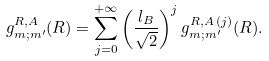Convert formula to latex. <formula><loc_0><loc_0><loc_500><loc_500>g _ { m ; m ^ { \prime } } ^ { R , A } ( { R } ) = \sum _ { j = 0 } ^ { + \infty } \left ( \frac { l _ { B } } { \sqrt { 2 } } \right ) ^ { j } g _ { m ; m ^ { \prime } } ^ { R , A \, ( j ) } ( { R } ) .</formula> 